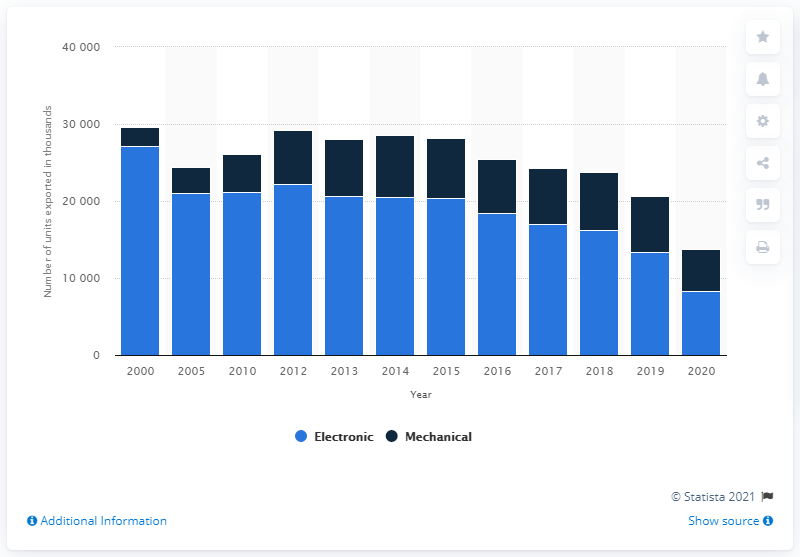Point out several critical features in this image. In 2020, a total of 5,481 units of mechanical Swiss watches were exported worldwide. 